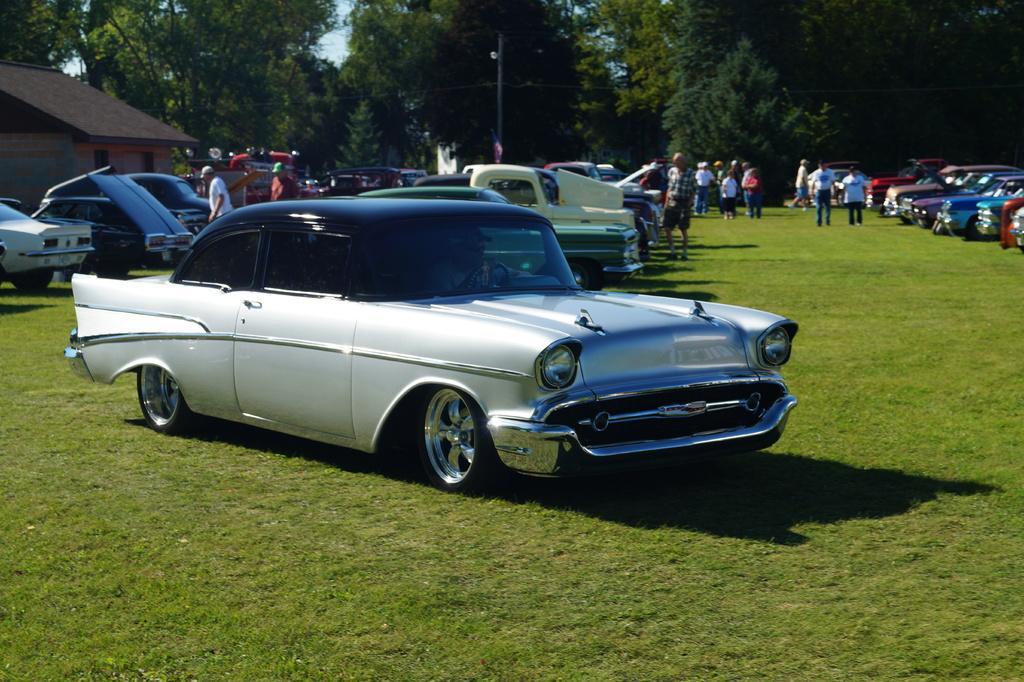Describe this image in one or two sentences. In this picture we can see some cars parked on the ground, at the bottom there is grass, we can see some people standing in the background, there are some trees here, we can see the sky at the top of the picture, on the left side there is a house. 